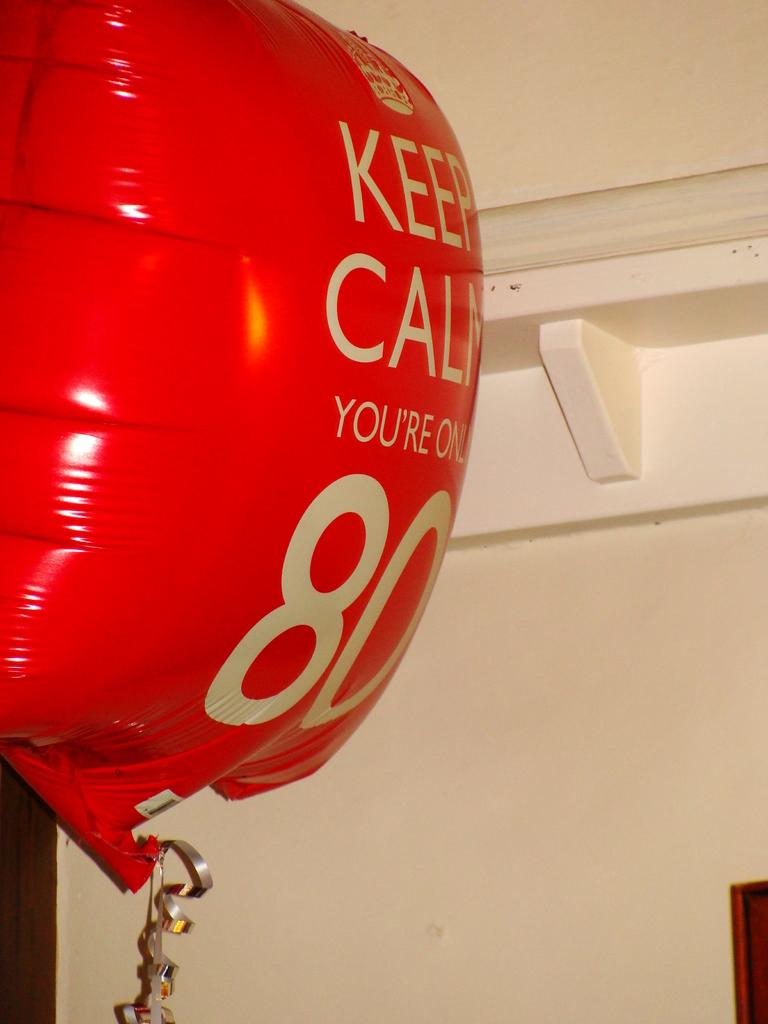<image>
Describe the image concisely. Red balloon that says the number 80 on it floating in the air. 